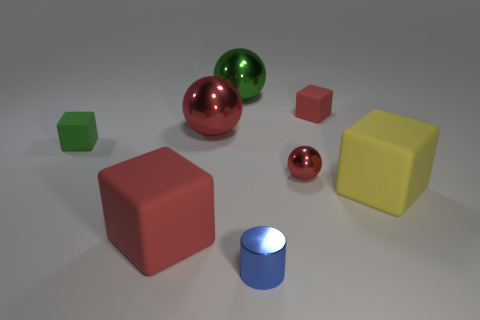Subtract 1 cubes. How many cubes are left? 3 Subtract all purple cubes. Subtract all green cylinders. How many cubes are left? 4 Add 1 large red cylinders. How many objects exist? 9 Subtract all cylinders. How many objects are left? 7 Subtract 0 brown spheres. How many objects are left? 8 Subtract all big red matte things. Subtract all big gray cubes. How many objects are left? 7 Add 2 big blocks. How many big blocks are left? 4 Add 8 blue cylinders. How many blue cylinders exist? 9 